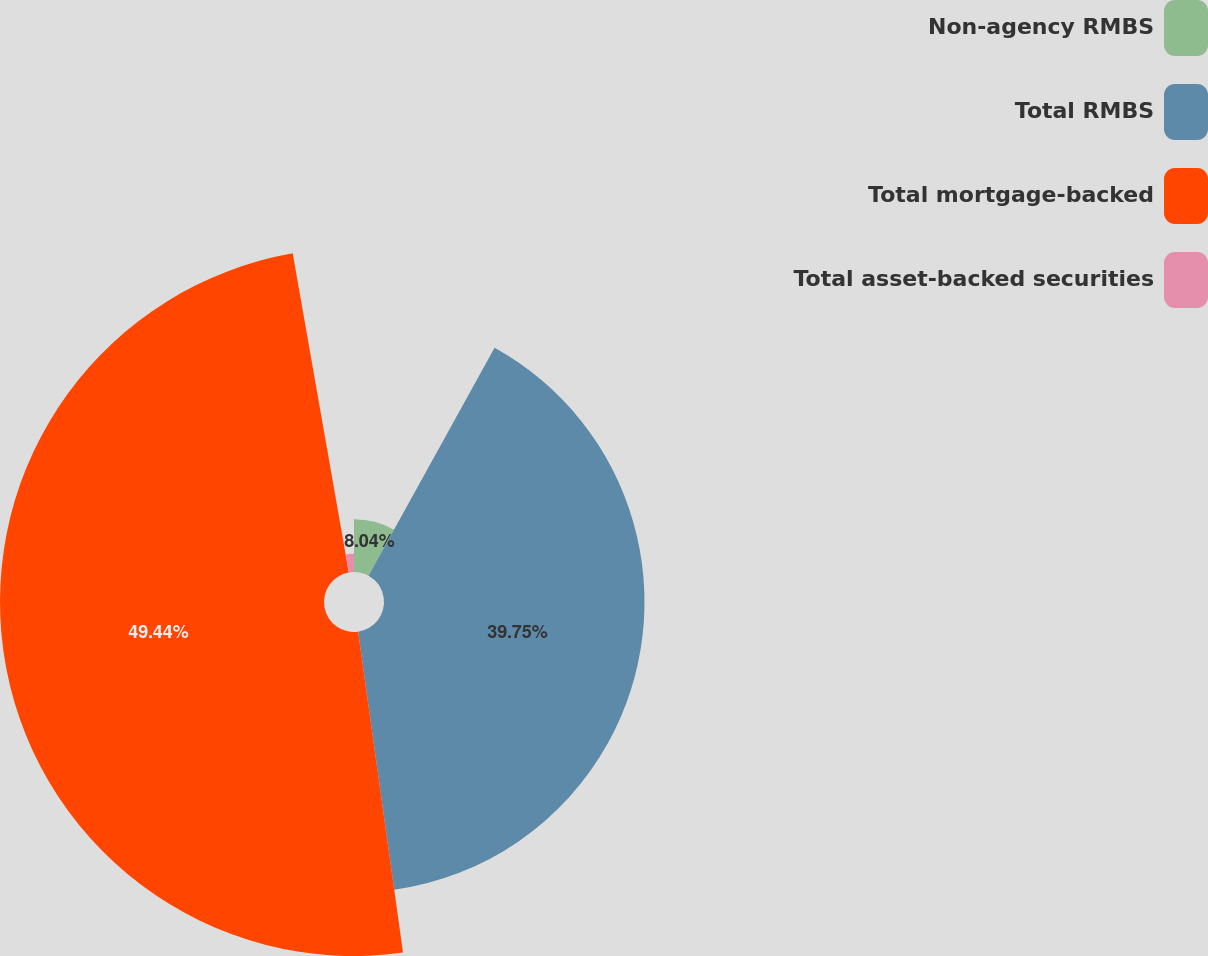Convert chart to OTSL. <chart><loc_0><loc_0><loc_500><loc_500><pie_chart><fcel>Non-agency RMBS<fcel>Total RMBS<fcel>Total mortgage-backed<fcel>Total asset-backed securities<nl><fcel>8.04%<fcel>39.75%<fcel>49.44%<fcel>2.77%<nl></chart> 